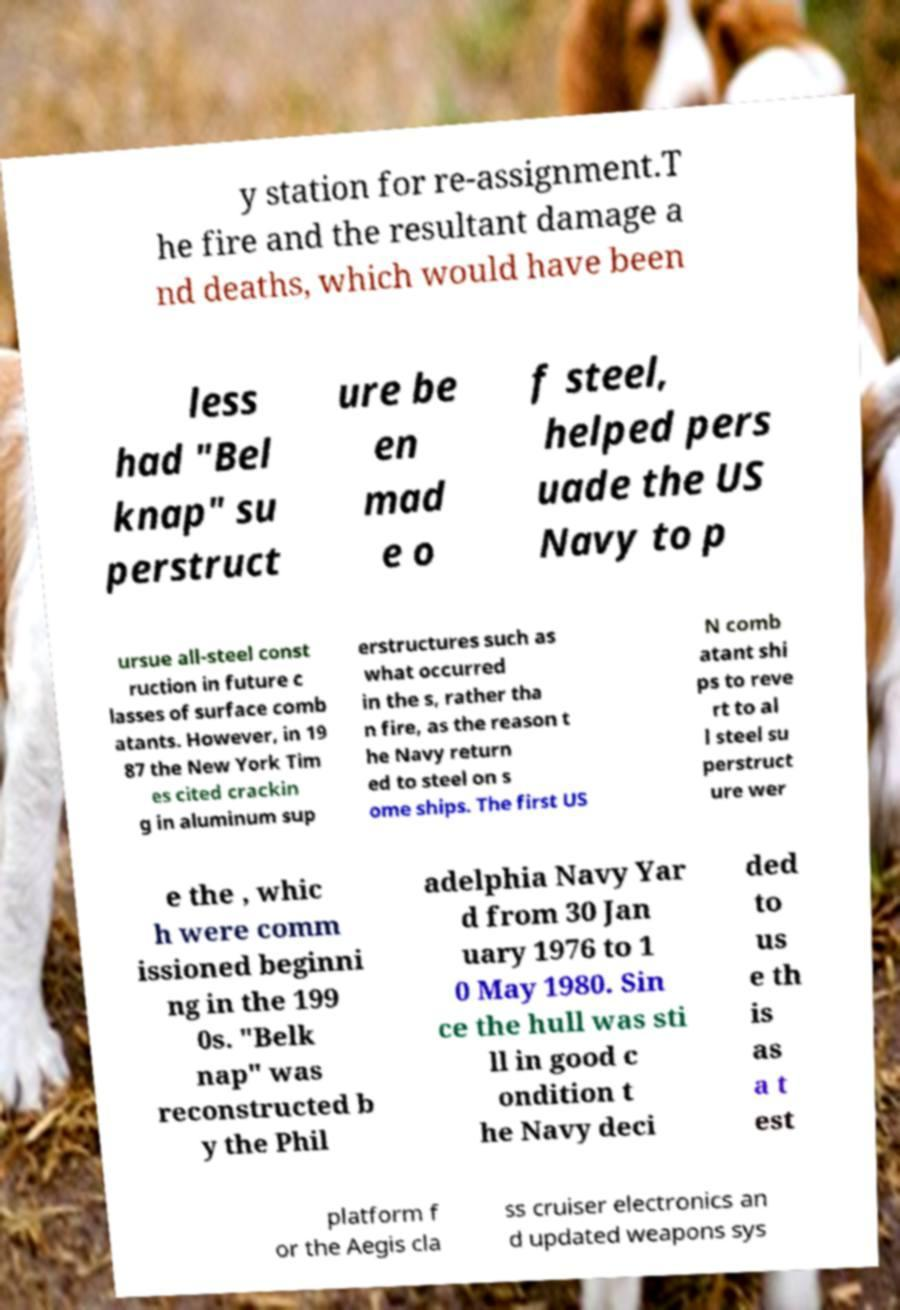For documentation purposes, I need the text within this image transcribed. Could you provide that? y station for re-assignment.T he fire and the resultant damage a nd deaths, which would have been less had "Bel knap" su perstruct ure be en mad e o f steel, helped pers uade the US Navy to p ursue all-steel const ruction in future c lasses of surface comb atants. However, in 19 87 the New York Tim es cited crackin g in aluminum sup erstructures such as what occurred in the s, rather tha n fire, as the reason t he Navy return ed to steel on s ome ships. The first US N comb atant shi ps to reve rt to al l steel su perstruct ure wer e the , whic h were comm issioned beginni ng in the 199 0s. "Belk nap" was reconstructed b y the Phil adelphia Navy Yar d from 30 Jan uary 1976 to 1 0 May 1980. Sin ce the hull was sti ll in good c ondition t he Navy deci ded to us e th is as a t est platform f or the Aegis cla ss cruiser electronics an d updated weapons sys 